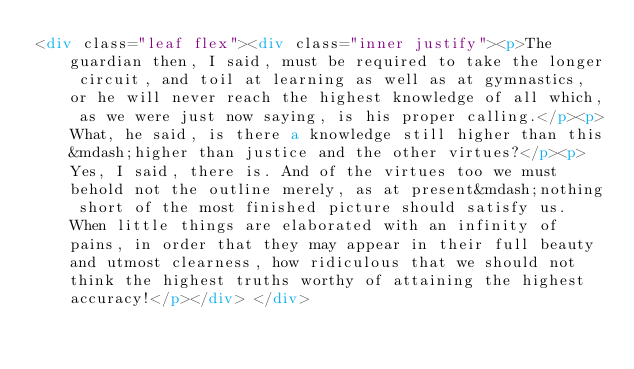Convert code to text. <code><loc_0><loc_0><loc_500><loc_500><_HTML_><div class="leaf flex"><div class="inner justify"><p>The guardian then, I said, must be required to take the longer circuit, and toil at learning as well as at gymnastics, or he will never reach the highest knowledge of all which, as we were just now saying, is his proper calling.</p><p>What, he said, is there a knowledge still higher than this&mdash;higher than justice and the other virtues?</p><p>Yes, I said, there is. And of the virtues too we must behold not the outline merely, as at present&mdash;nothing short of the most finished picture should satisfy us. When little things are elaborated with an infinity of pains, in order that they may appear in their full beauty and utmost clearness, how ridiculous that we should not think the highest truths worthy of attaining the highest accuracy!</p></div> </div></code> 